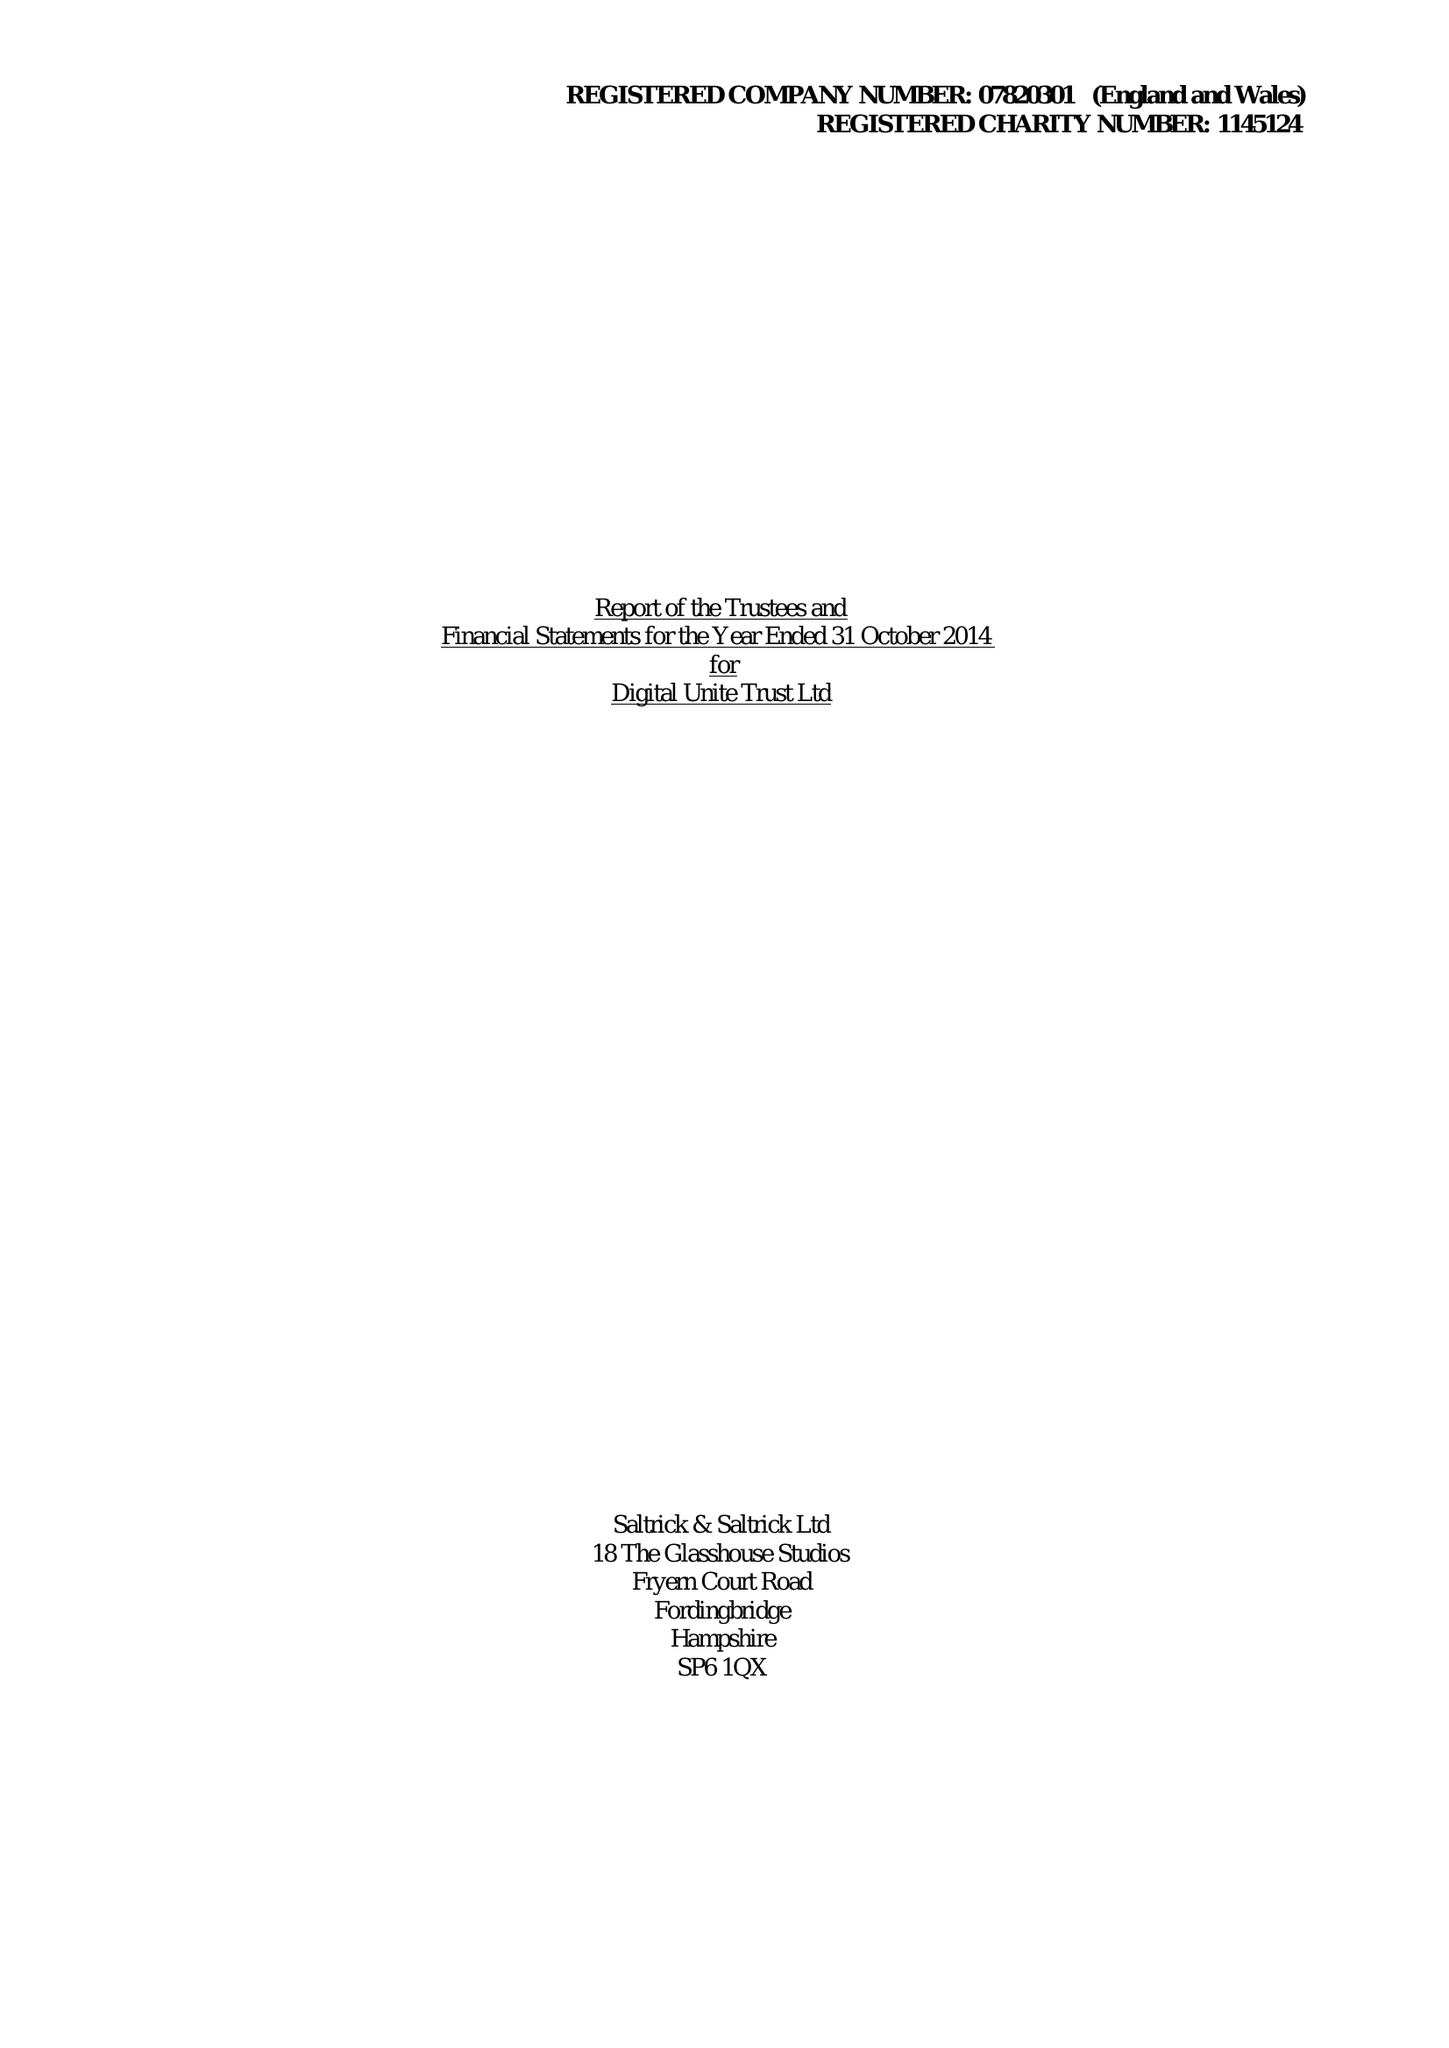What is the value for the charity_number?
Answer the question using a single word or phrase. 1145124 